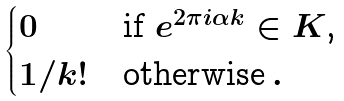<formula> <loc_0><loc_0><loc_500><loc_500>\begin{cases} 0 & \text {if $e^{2 \pi i\alpha k} \in K$,} \\ 1 / k ! & \text {otherwise} \, . \end{cases}</formula> 